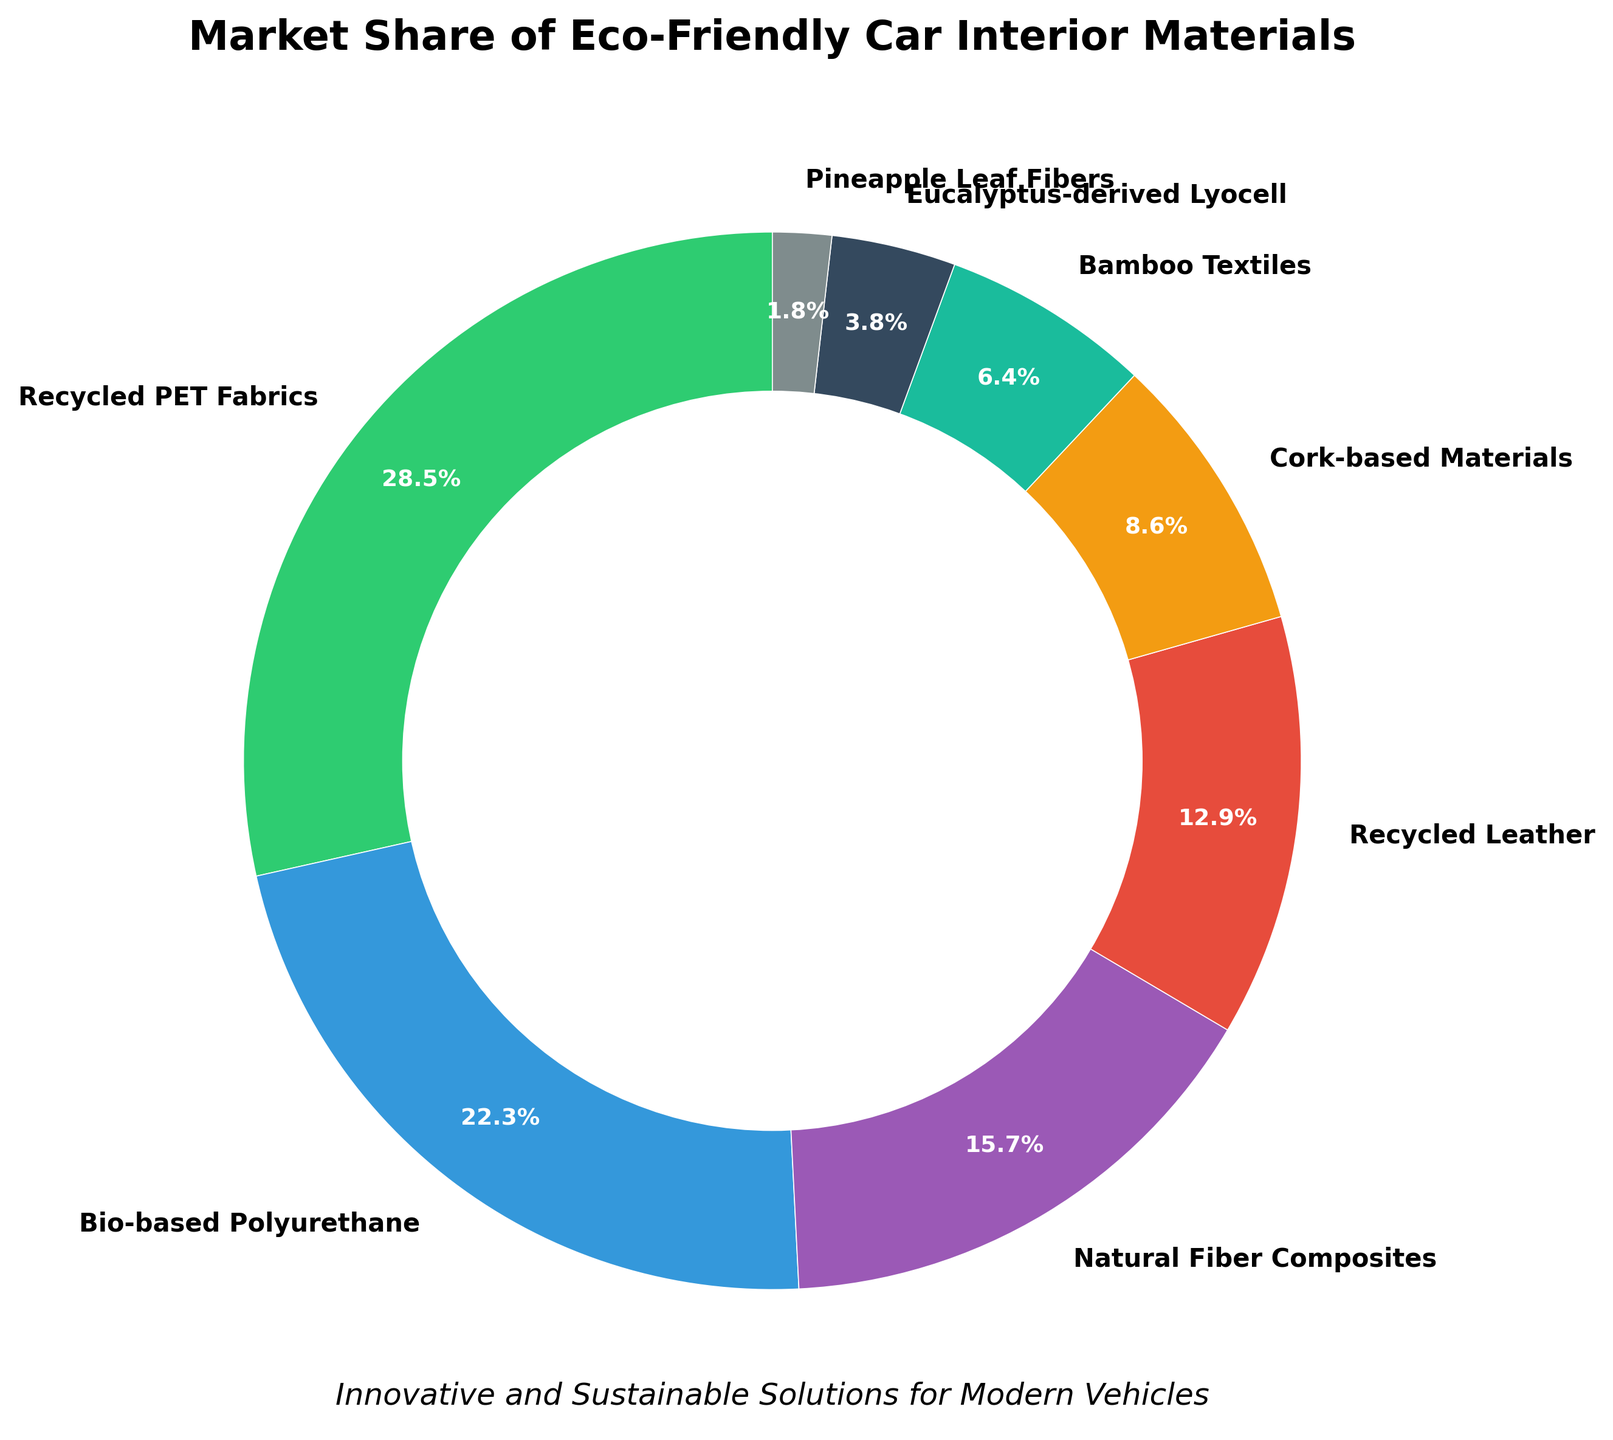What is the market share percentage of Bio-based Polyurethane? The pie chart shows the market share percentages of various eco-friendly car interior materials. Locate the segment labeled "Bio-based Polyurethane" to find the corresponding percentage.
Answer: 22.3% Which material has the smallest market share? Look at the pie chart and identify the segment with the smallest size. Find the material label associated with this smallest segment.
Answer: Pineapple Leaf Fibers What is the combined market share percentage of Recycled PET Fabrics and Recycled Leather? Find the percentages for Recycled PET Fabrics and Recycled Leather from the pie chart, and then sum them up (28.5% for Recycled PET Fabrics and 12.9% for Recycled Leather).
Answer: 41.4% What is the difference in market share between Natural Fiber Composites and Bamboo Textiles? Find the market share percentages for Natural Fiber Composites (15.7%) and Bamboo Textiles (6.4%), and then subtract the smaller percentage from the larger one (15.7% - 6.4%).
Answer: 9.3% Is the market share of Bio-based Polyurethane greater than that of Natural Fiber Composites? Compare the market share percentages from the pie chart: Bio-based Polyurethane (22.3%) and Natural Fiber Composites (15.7%).
Answer: Yes Which materials occupy more than 10% of the market share? Identify the segments of the pie chart with market share percentages greater than 10%.
Answer: Recycled PET Fabrics, Bio-based Polyurethane, Natural Fiber Composites, Recycled Leather How many materials have a market share percentage less than 10%? Count the number of segments in the pie chart that represent materials with less than 10% market share.
Answer: 4 What is the market share difference between the largest and smallest segments? Identify the largest (Recycled PET Fabrics at 28.5%) and smallest (Pineapple Leaf Fibers at 1.8%) segments from the pie chart, then calculate the difference (28.5% - 1.8%).
Answer: 26.7% Which color represents Cork-based Materials in the pie chart? Look at the visual representation of the pie chart and identify the color associated with the label "Cork-based Materials."
Answer: Orange (or the fifth color in the custom palette) 